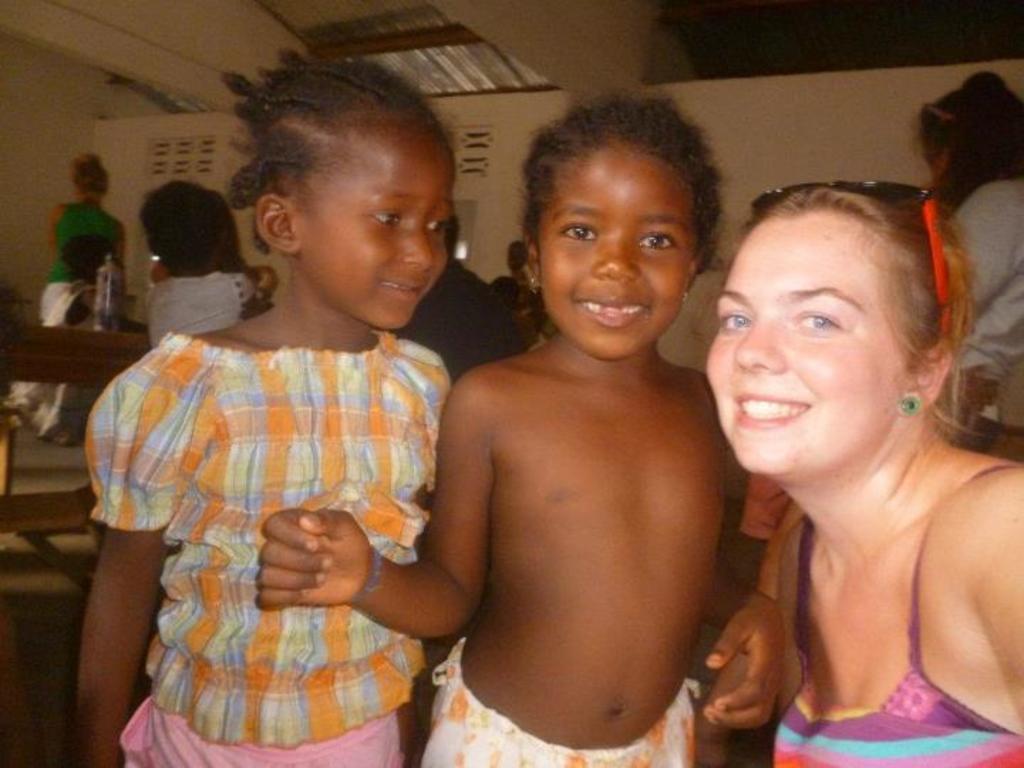How would you summarize this image in a sentence or two? These three people are smiling. Background we can see people and wall. 